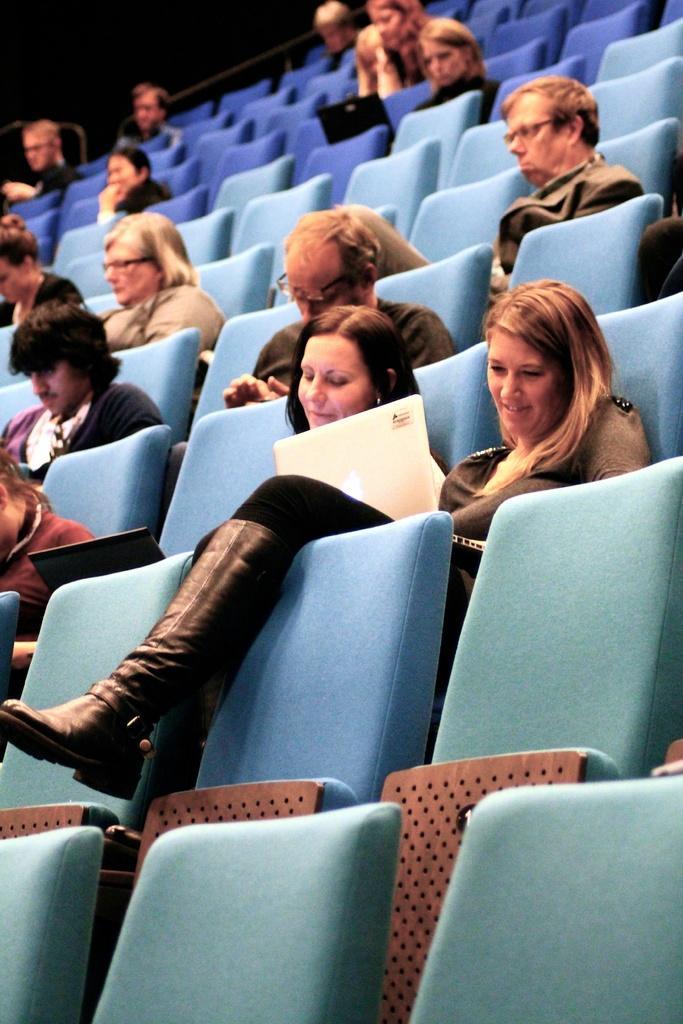Could you give a brief overview of what you see in this image? In this image I can see number of people are sitting on chairs. I can also see few laptops and few people are wearing specs. 